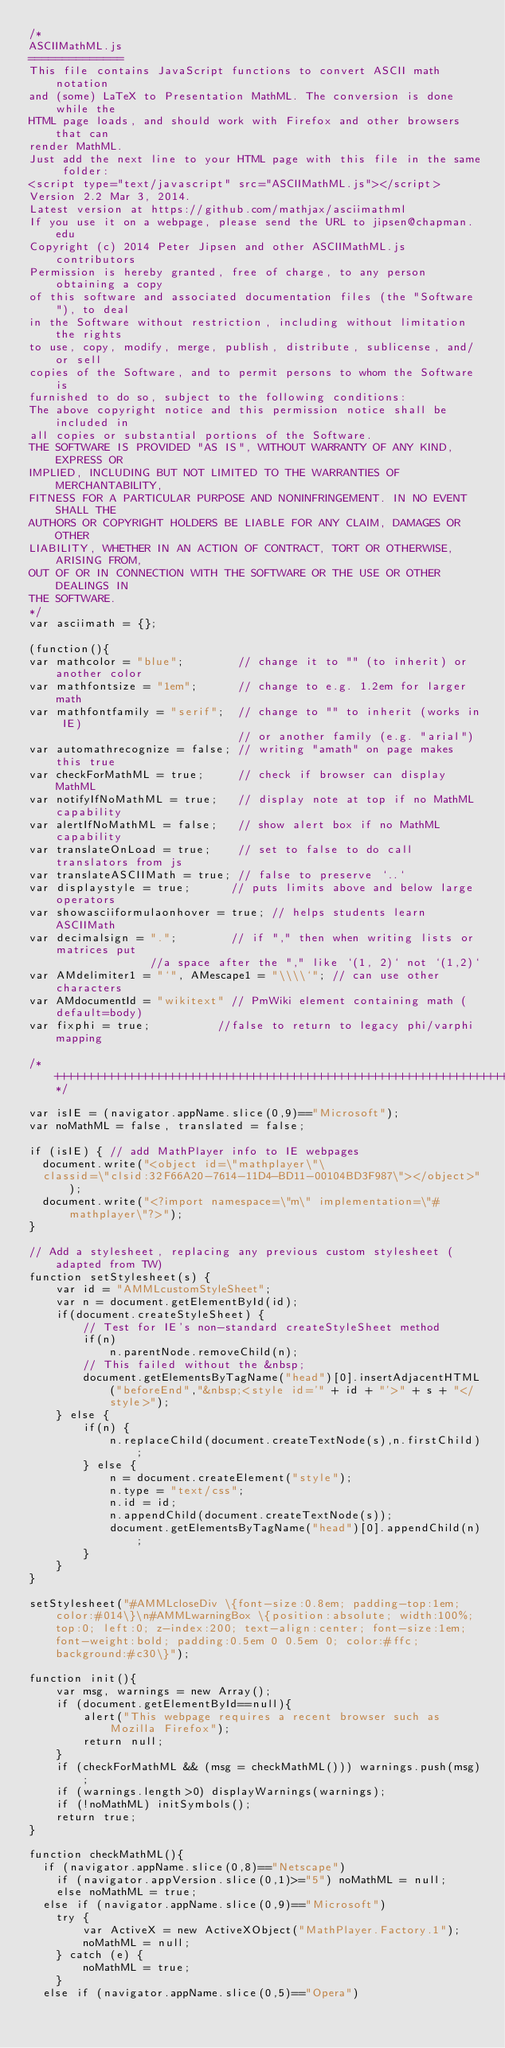<code> <loc_0><loc_0><loc_500><loc_500><_JavaScript_>/*
ASCIIMathML.js
==============
This file contains JavaScript functions to convert ASCII math notation
and (some) LaTeX to Presentation MathML. The conversion is done while the
HTML page loads, and should work with Firefox and other browsers that can
render MathML.
Just add the next line to your HTML page with this file in the same folder:
<script type="text/javascript" src="ASCIIMathML.js"></script>
Version 2.2 Mar 3, 2014.
Latest version at https://github.com/mathjax/asciimathml
If you use it on a webpage, please send the URL to jipsen@chapman.edu
Copyright (c) 2014 Peter Jipsen and other ASCIIMathML.js contributors
Permission is hereby granted, free of charge, to any person obtaining a copy
of this software and associated documentation files (the "Software"), to deal
in the Software without restriction, including without limitation the rights
to use, copy, modify, merge, publish, distribute, sublicense, and/or sell
copies of the Software, and to permit persons to whom the Software is
furnished to do so, subject to the following conditions:
The above copyright notice and this permission notice shall be included in
all copies or substantial portions of the Software.
THE SOFTWARE IS PROVIDED "AS IS", WITHOUT WARRANTY OF ANY KIND, EXPRESS OR
IMPLIED, INCLUDING BUT NOT LIMITED TO THE WARRANTIES OF MERCHANTABILITY,
FITNESS FOR A PARTICULAR PURPOSE AND NONINFRINGEMENT. IN NO EVENT SHALL THE
AUTHORS OR COPYRIGHT HOLDERS BE LIABLE FOR ANY CLAIM, DAMAGES OR OTHER
LIABILITY, WHETHER IN AN ACTION OF CONTRACT, TORT OR OTHERWISE, ARISING FROM,
OUT OF OR IN CONNECTION WITH THE SOFTWARE OR THE USE OR OTHER DEALINGS IN
THE SOFTWARE.
*/
var asciimath = {};

(function(){
var mathcolor = "blue";        // change it to "" (to inherit) or another color
var mathfontsize = "1em";      // change to e.g. 1.2em for larger math
var mathfontfamily = "serif";  // change to "" to inherit (works in IE)
                               // or another family (e.g. "arial")
var automathrecognize = false; // writing "amath" on page makes this true
var checkForMathML = true;     // check if browser can display MathML
var notifyIfNoMathML = true;   // display note at top if no MathML capability
var alertIfNoMathML = false;   // show alert box if no MathML capability
var translateOnLoad = true;    // set to false to do call translators from js
var translateASCIIMath = true; // false to preserve `..`
var displaystyle = true;      // puts limits above and below large operators
var showasciiformulaonhover = true; // helps students learn ASCIIMath
var decimalsign = ".";        // if "," then when writing lists or matrices put
			      //a space after the "," like `(1, 2)` not `(1,2)`
var AMdelimiter1 = "`", AMescape1 = "\\\\`"; // can use other characters
var AMdocumentId = "wikitext" // PmWiki element containing math (default=body)
var fixphi = true;  		//false to return to legacy phi/varphi mapping

/*++++++++++++++++++++++++++++++++++++++++++++++++++++++++++++++++++++++++++*/

var isIE = (navigator.appName.slice(0,9)=="Microsoft");
var noMathML = false, translated = false;

if (isIE) { // add MathPlayer info to IE webpages
  document.write("<object id=\"mathplayer\"\
  classid=\"clsid:32F66A20-7614-11D4-BD11-00104BD3F987\"></object>");
  document.write("<?import namespace=\"m\" implementation=\"#mathplayer\"?>");
}

// Add a stylesheet, replacing any previous custom stylesheet (adapted from TW)
function setStylesheet(s) {
	var id = "AMMLcustomStyleSheet";
	var n = document.getElementById(id);
	if(document.createStyleSheet) {
		// Test for IE's non-standard createStyleSheet method
		if(n)
			n.parentNode.removeChild(n);
		// This failed without the &nbsp;
		document.getElementsByTagName("head")[0].insertAdjacentHTML("beforeEnd","&nbsp;<style id='" + id + "'>" + s + "</style>");
	} else {
		if(n) {
			n.replaceChild(document.createTextNode(s),n.firstChild);
		} else {
			n = document.createElement("style");
			n.type = "text/css";
			n.id = id;
			n.appendChild(document.createTextNode(s));
			document.getElementsByTagName("head")[0].appendChild(n);
		}
	}
}

setStylesheet("#AMMLcloseDiv \{font-size:0.8em; padding-top:1em; color:#014\}\n#AMMLwarningBox \{position:absolute; width:100%; top:0; left:0; z-index:200; text-align:center; font-size:1em; font-weight:bold; padding:0.5em 0 0.5em 0; color:#ffc; background:#c30\}");

function init(){
	var msg, warnings = new Array();
	if (document.getElementById==null){
		alert("This webpage requires a recent browser such as Mozilla Firefox");
		return null;
	}
	if (checkForMathML && (msg = checkMathML())) warnings.push(msg);
	if (warnings.length>0) displayWarnings(warnings);
	if (!noMathML) initSymbols();
	return true;
}

function checkMathML(){
  if (navigator.appName.slice(0,8)=="Netscape")
    if (navigator.appVersion.slice(0,1)>="5") noMathML = null;
    else noMathML = true;
  else if (navigator.appName.slice(0,9)=="Microsoft")
    try {
        var ActiveX = new ActiveXObject("MathPlayer.Factory.1");
        noMathML = null;
    } catch (e) {
        noMathML = true;
    }
  else if (navigator.appName.slice(0,5)=="Opera")</code> 